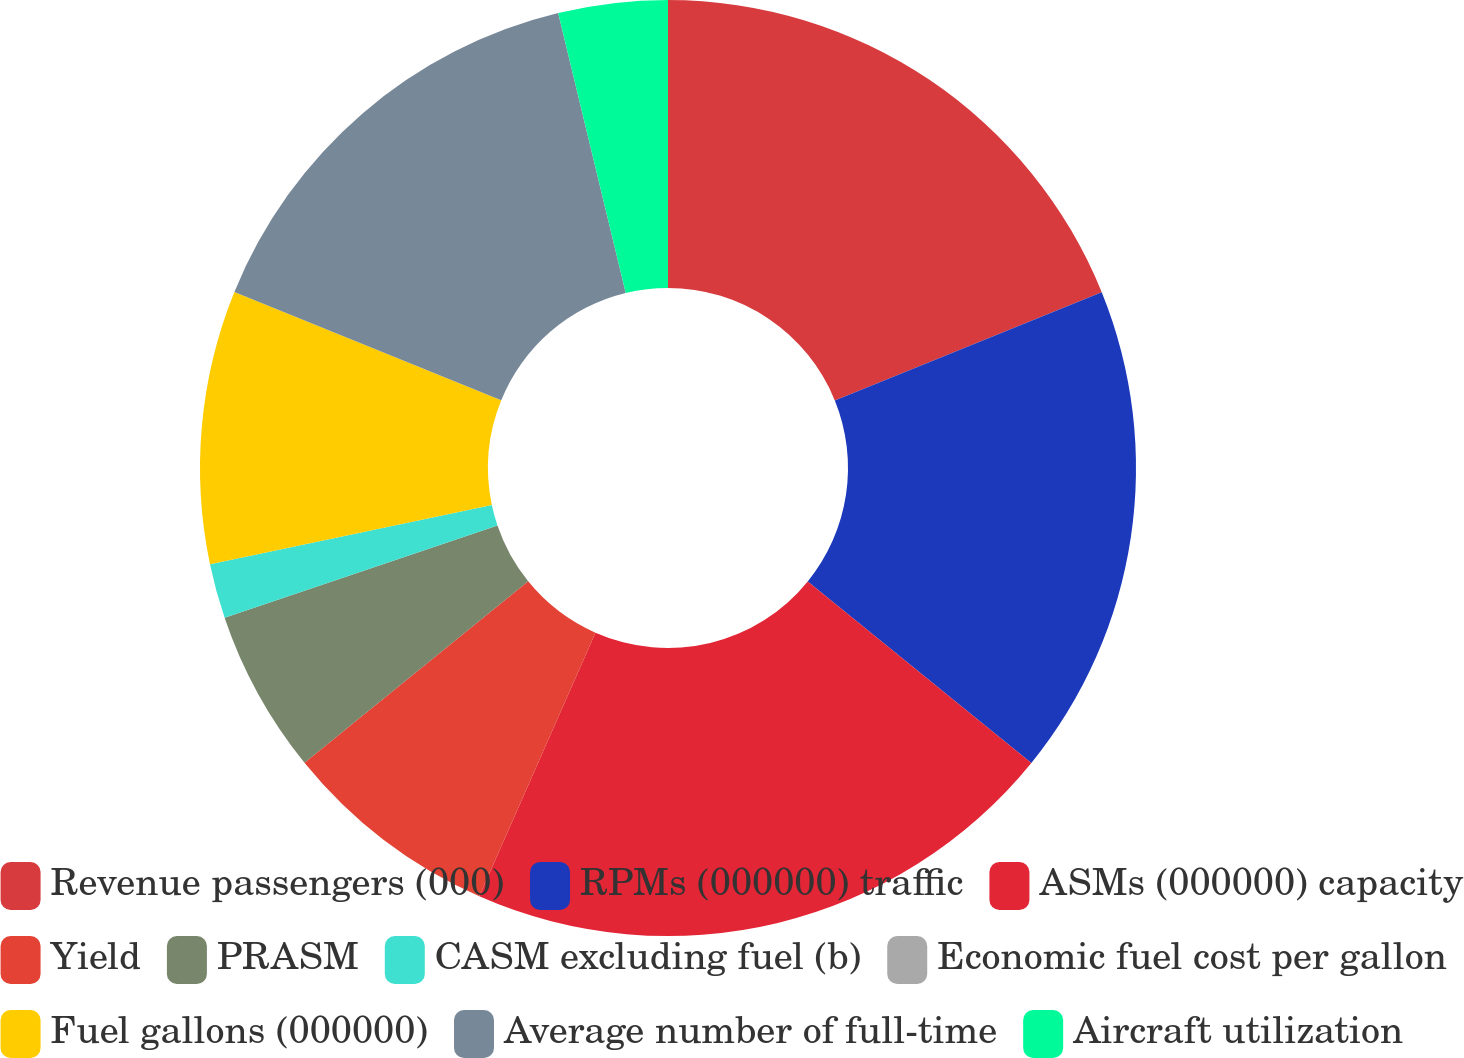Convert chart. <chart><loc_0><loc_0><loc_500><loc_500><pie_chart><fcel>Revenue passengers (000)<fcel>RPMs (000000) traffic<fcel>ASMs (000000) capacity<fcel>Yield<fcel>PRASM<fcel>CASM excluding fuel (b)<fcel>Economic fuel cost per gallon<fcel>Fuel gallons (000000)<fcel>Average number of full-time<fcel>Aircraft utilization<nl><fcel>18.87%<fcel>16.98%<fcel>20.75%<fcel>7.55%<fcel>5.66%<fcel>1.89%<fcel>0.0%<fcel>9.43%<fcel>15.09%<fcel>3.77%<nl></chart> 